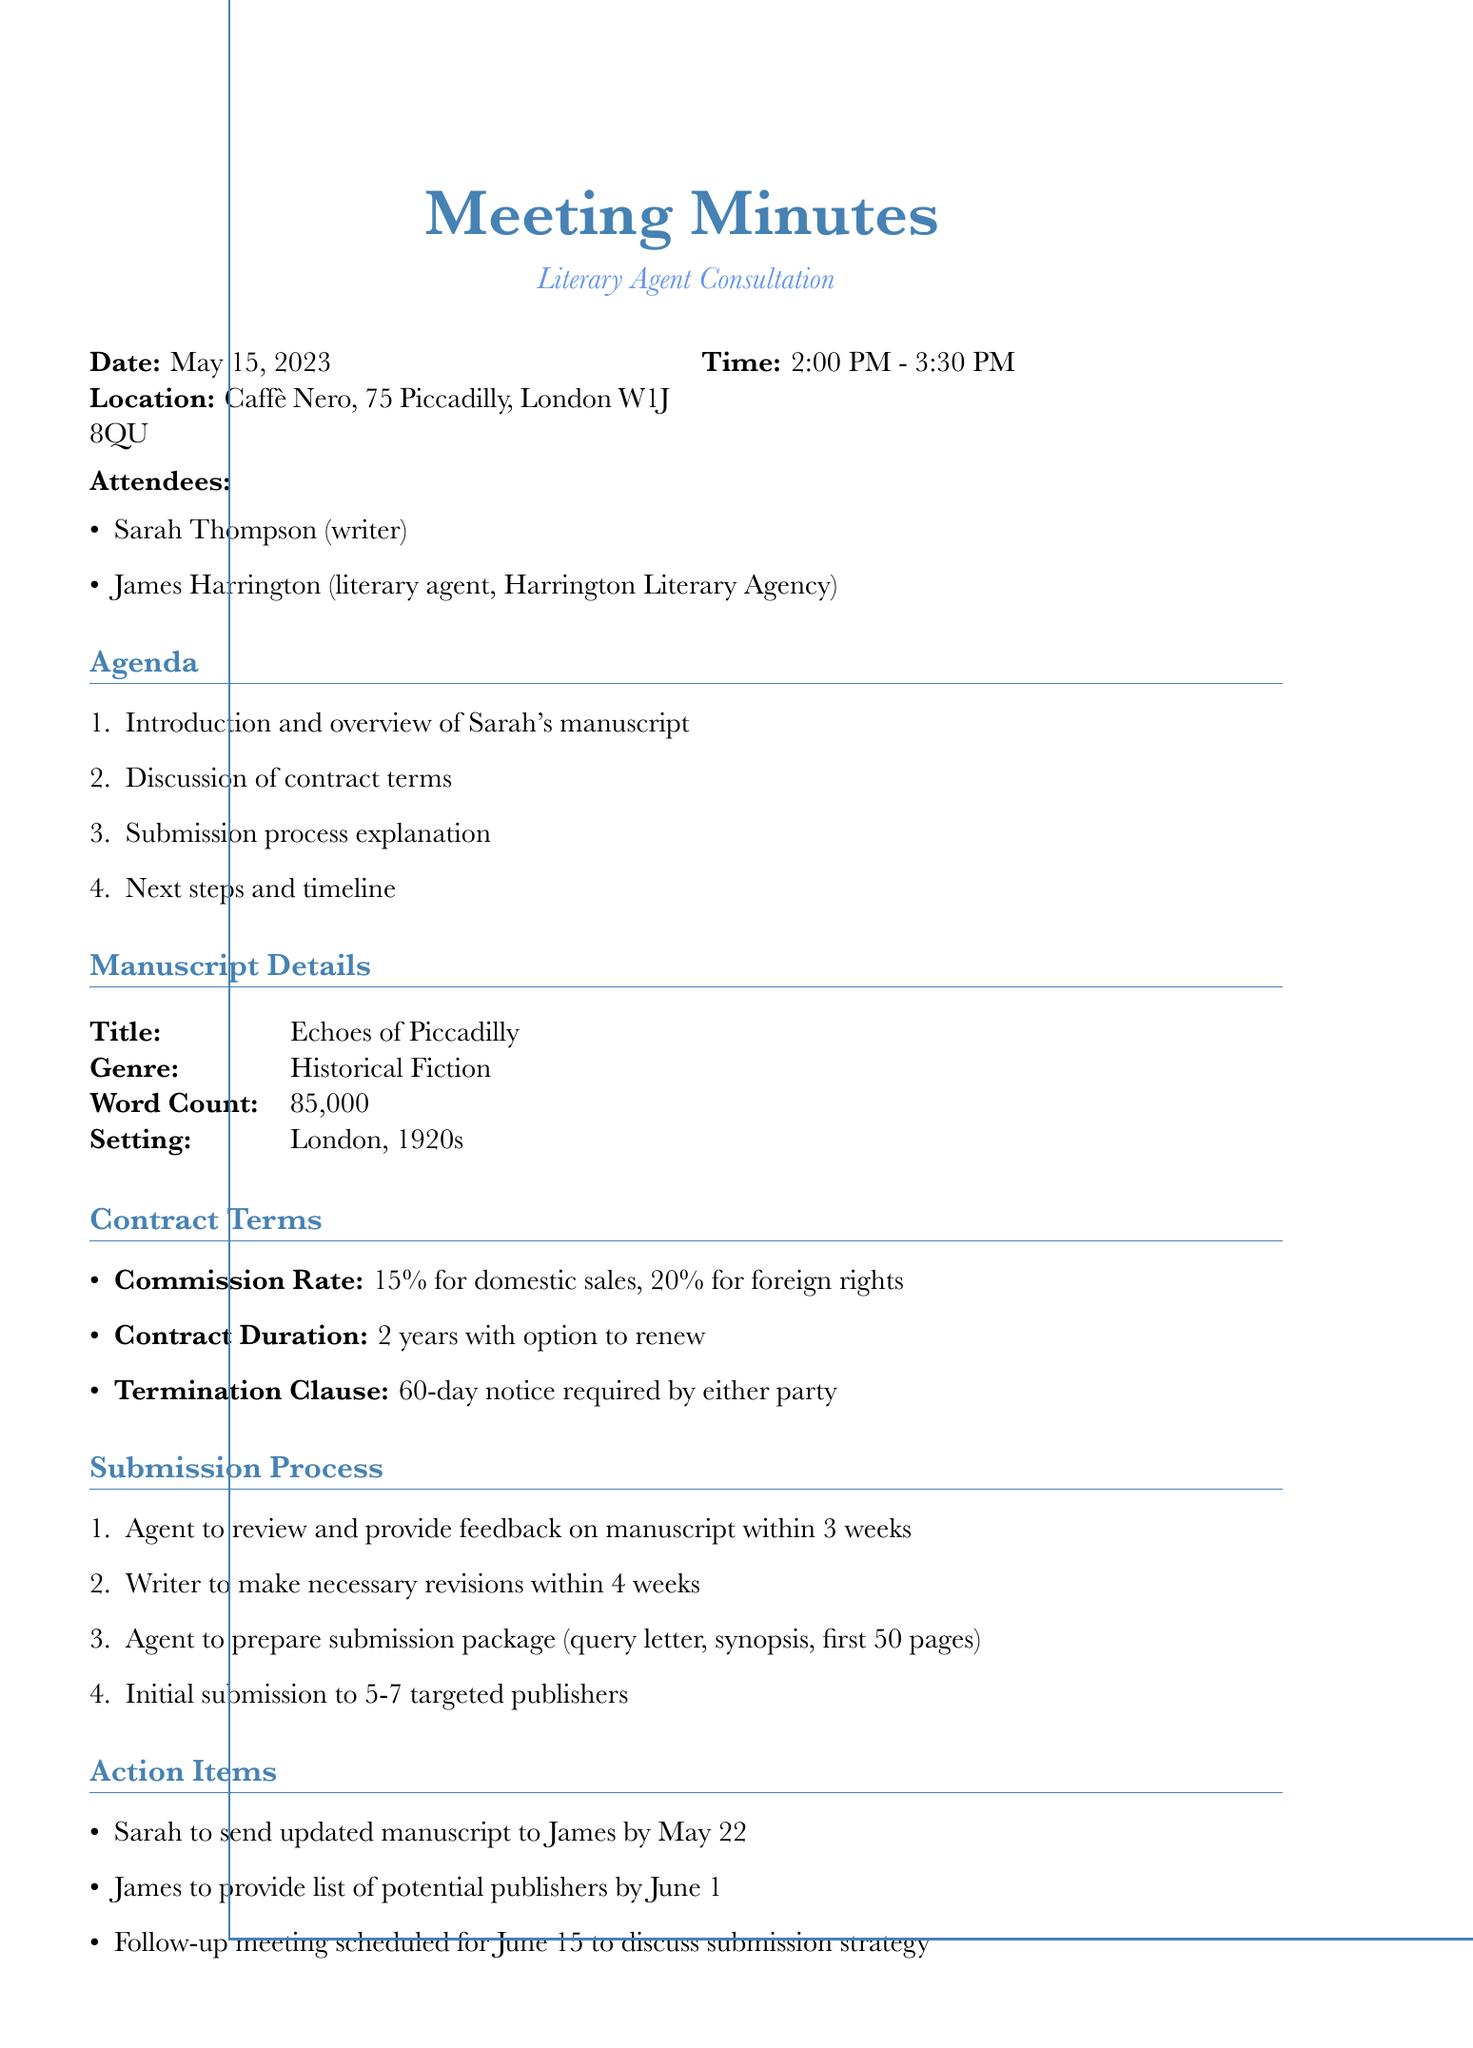What is the date of the meeting? The date of the meeting is explicitly stated in the document under meeting details.
Answer: May 15, 2023 Who is the literary agent mentioned in the document? The document lists the attendees, one of whom is a literary agent.
Answer: James Harrington What is the commission rate for foreign rights? The commission rate is detailed in the contract terms section of the document.
Answer: 20% How long does Sarah have to revise her manuscript? The submission process states the timeframe allowed for revisions.
Answer: 4 weeks What is the title of Sarah's manuscript? The document lists the manuscript details, which includes the title.
Answer: Echoes of Piccadilly How many targeted publishers is the initial submission intended for? The number of publishers for the initial submission is specified in the submission process.
Answer: 5-7 What is the contract duration mentioned? The contract terms section outlines the duration of the contract.
Answer: 2 years When is the follow-up meeting scheduled? The action items section states the date for the next meeting.
Answer: June 15 What type of fiction is Sarah's manuscript categorized under? The manuscript details describe the genre of the work.
Answer: Historical Fiction 